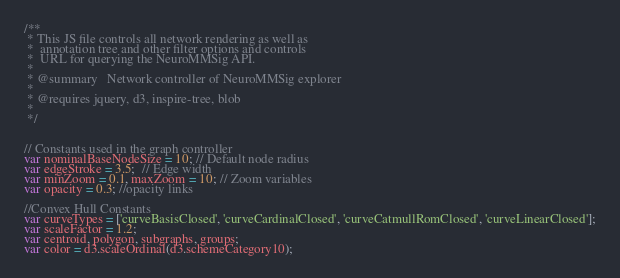<code> <loc_0><loc_0><loc_500><loc_500><_JavaScript_>/**
 * This JS file controls all network rendering as well as
 *  annotation tree and other filter options and controls
 *  URL for querying the NeuroMMSig API.
 *
 * @summary   Network controller of NeuroMMSig explorer
 *
 * @requires jquery, d3, inspire-tree, blob
 *
 */


// Constants used in the graph controller
var nominalBaseNodeSize = 10; // Default node radius
var edgeStroke = 3.5;  // Edge width
var minZoom = 0.1, maxZoom = 10; // Zoom variables
var opacity = 0.3; //opacity links

//Convex Hull Constants
var curveTypes = ['curveBasisClosed', 'curveCardinalClosed', 'curveCatmullRomClosed', 'curveLinearClosed'];
var scaleFactor = 1.2;
var centroid, polygon, subgraphs, groups;
var color = d3.scaleOrdinal(d3.schemeCategory10);</code> 